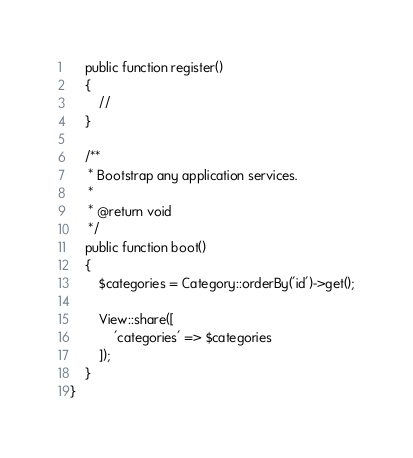<code> <loc_0><loc_0><loc_500><loc_500><_PHP_>    public function register()
    {
        //
    }

    /**
     * Bootstrap any application services.
     *
     * @return void
     */
    public function boot()
    {
        $categories = Category::orderBy('id')->get();

        View::share([
            'categories' => $categories
        ]);
    }
}
</code> 